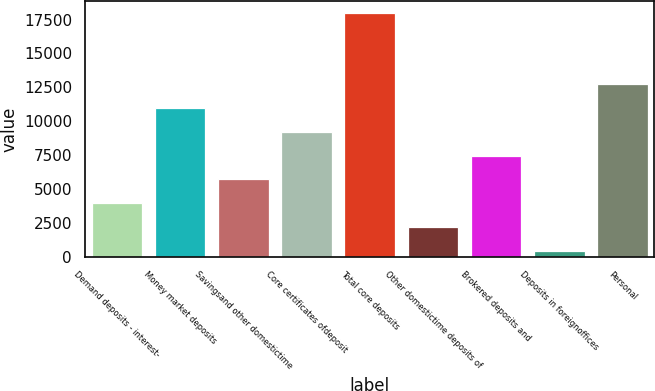<chart> <loc_0><loc_0><loc_500><loc_500><bar_chart><fcel>Demand deposits - interest-<fcel>Money market deposits<fcel>Savingsand other domestictime<fcel>Core certificates ofdeposit<fcel>Total core deposits<fcel>Other domestictime deposits of<fcel>Brokered deposits and<fcel>Deposits in foreignoffices<fcel>Personal<nl><fcel>3971.2<fcel>10971.6<fcel>5721.3<fcel>9221.5<fcel>17972<fcel>2221.1<fcel>7471.4<fcel>471<fcel>12721.7<nl></chart> 